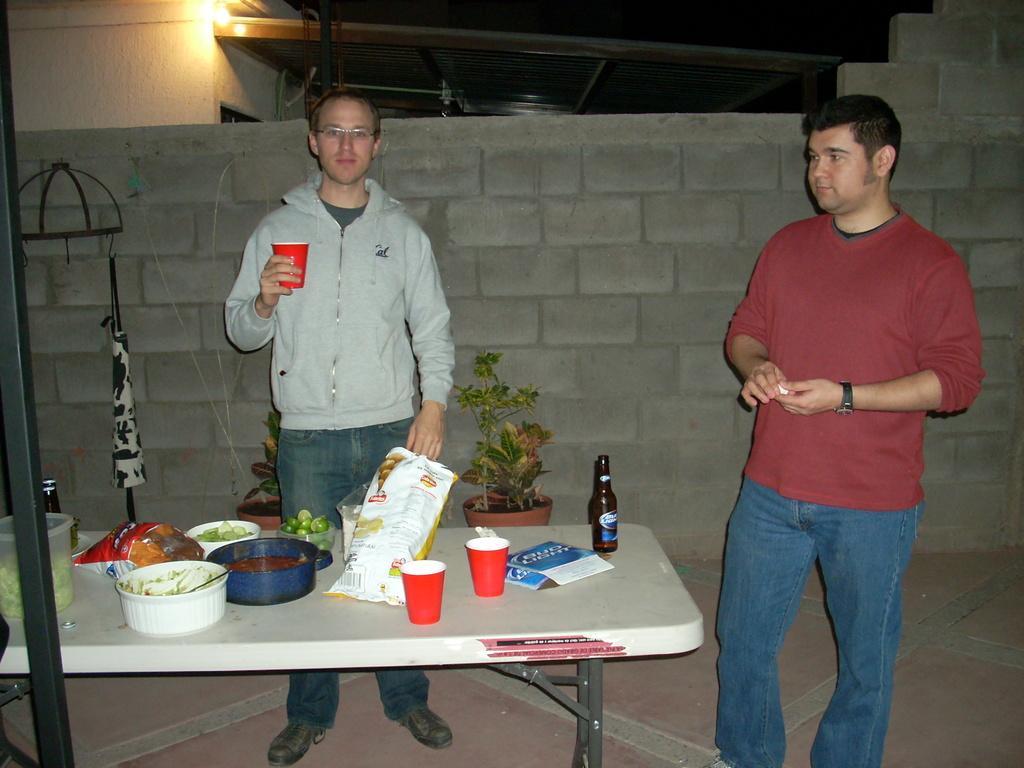How would you summarize this image in a sentence or two? In this image I can see two men are standing. I can also see he is wearing a specs and holding a glass. On this table I can see a bottle, two glasses and few more stuffs. In the background I can see plants. 